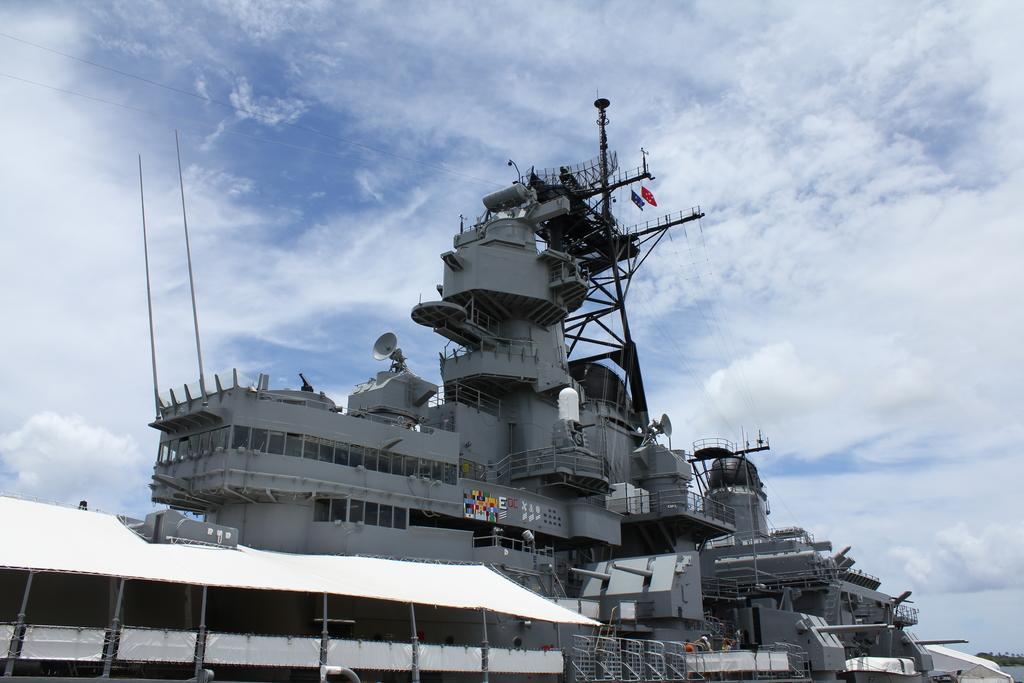Please provide a concise description of this image. Here we can see a battleship and we can also see poles,fences,tent,posters on the metal wall,flags. In the background there are trees,water and clouds in the sky. 